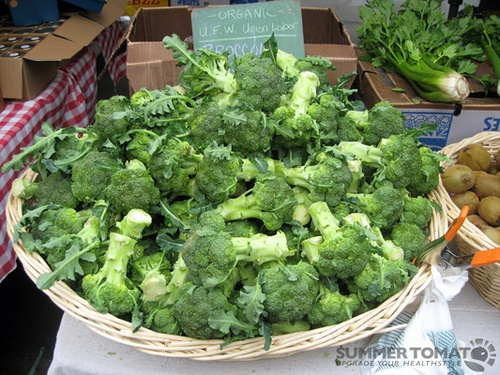Describe the objects in this image and their specific colors. I can see broccoli in black, green, darkgreen, and lightgreen tones, dining table in black, lightgray, darkgray, and gray tones, dining table in maroon, black, and gray tones, broccoli in black, green, darkgreen, and lightgreen tones, and broccoli in black, darkgreen, and green tones in this image. 